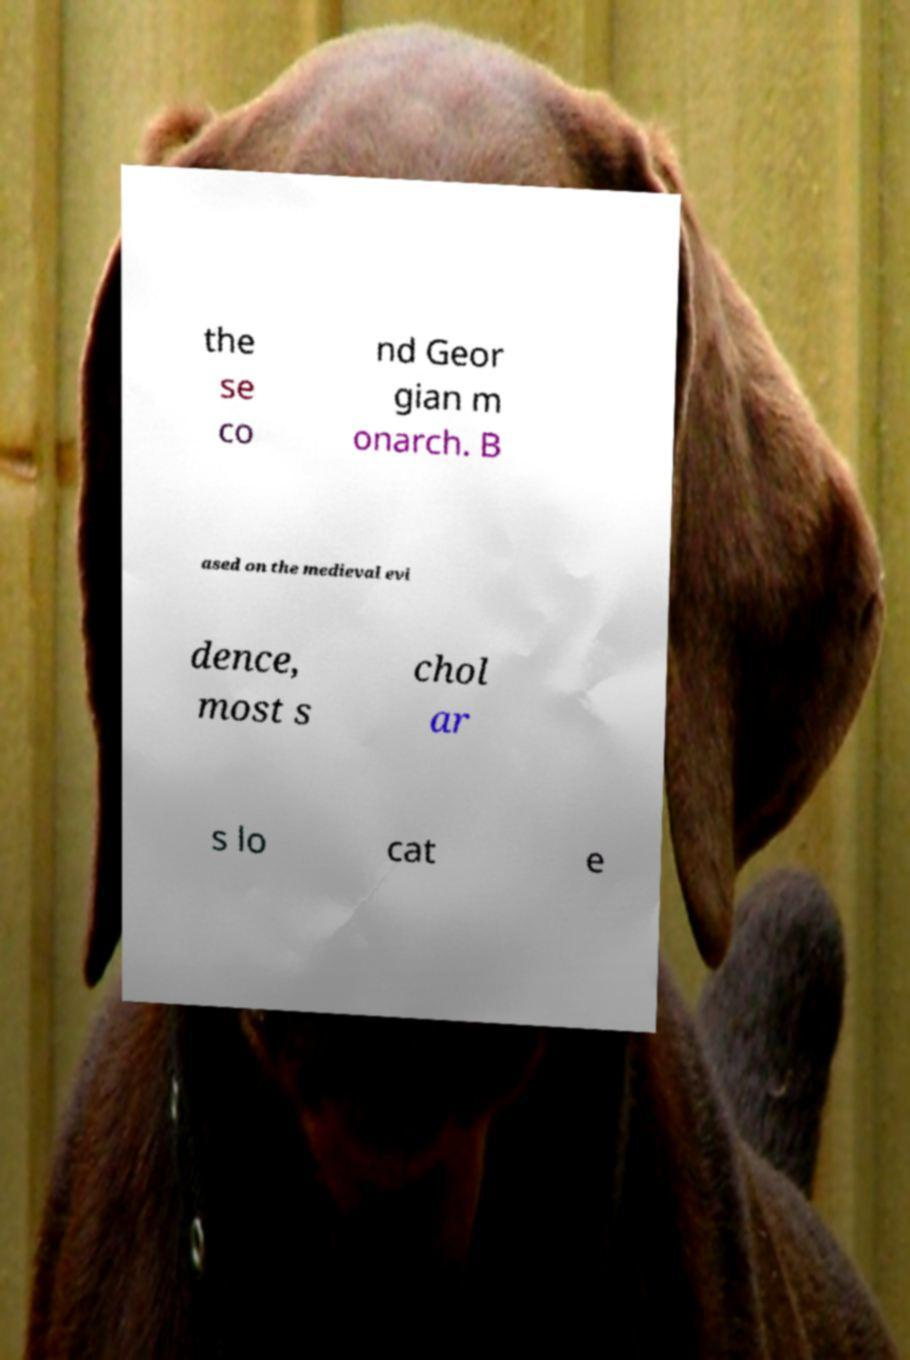Please identify and transcribe the text found in this image. the se co nd Geor gian m onarch. B ased on the medieval evi dence, most s chol ar s lo cat e 